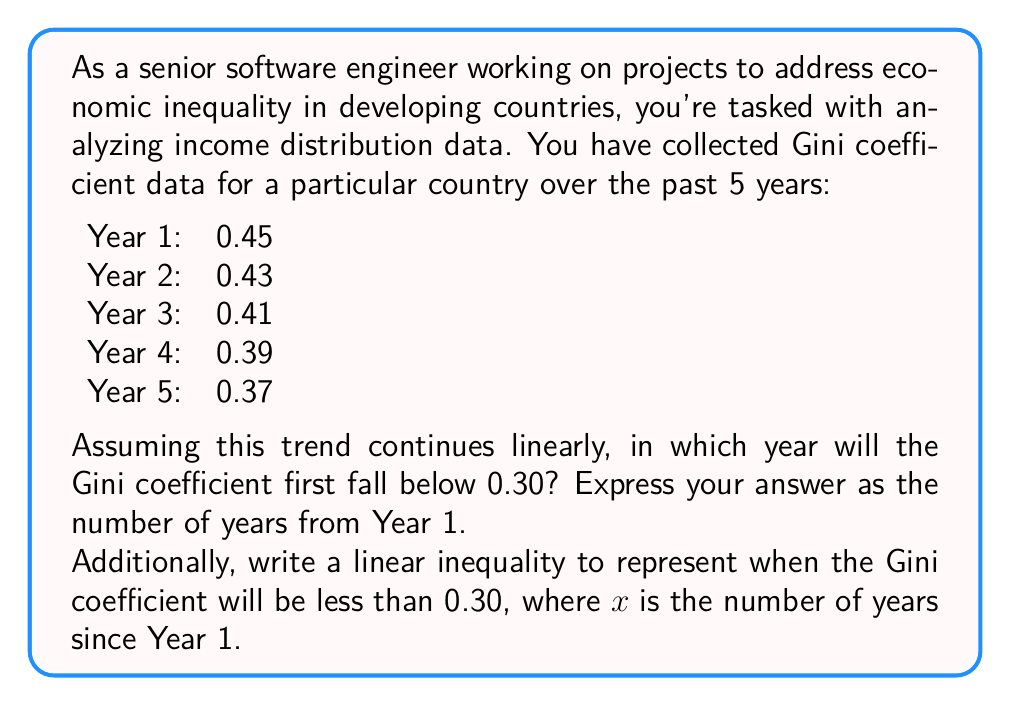Give your solution to this math problem. To solve this problem, we need to follow these steps:

1. Find the linear equation that represents the trend in Gini coefficient values.
2. Use this equation to determine when the Gini coefficient will fall below 0.30.
3. Express the solution as a linear inequality.

Step 1: Finding the linear equation

We can see that the Gini coefficient is decreasing by 0.02 each year. Let's express this as a linear equation:

$$y = mx + b$$

Where:
$y$ is the Gini coefficient
$x$ is the number of years since Year 1
$m$ is the slope (rate of change)
$b$ is the y-intercept (initial value)

We can calculate:
$m = -0.02$ (decreasing by 0.02 each year)
$b = 0.45$ (the Gini coefficient in Year 1)

So our equation is:

$$y = -0.02x + 0.45$$

Step 2: Determining when Gini coefficient falls below 0.30

We want to find $x$ when $y < 0.30$:

$$0.30 > -0.02x + 0.45$$

Solving for $x$:

$$-0.15 > -0.02x$$
$$7.5 < x$$

Since $x$ must be an integer (we're counting in years), the first year when the Gini coefficient will be below 0.30 is when $x = 8$.

Step 3: Expressing as a linear inequality

The inequality representing when the Gini coefficient will be less than 0.30 is:

$$-0.02x + 0.45 < 0.30$$

Or simplified:

$$x > 7.5$$
Answer: The Gini coefficient will first fall below 0.30 in Year 8 (7 years from Year 1).

The linear inequality representing when the Gini coefficient will be less than 0.30 is:

$$x > 7.5$$

Where $x$ is the number of years since Year 1. 